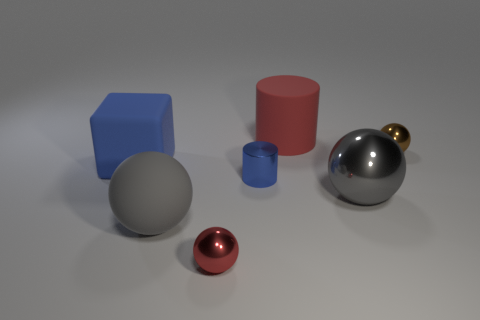Subtract all large gray metallic balls. How many balls are left? 3 Subtract all brown blocks. How many gray spheres are left? 2 Subtract all red spheres. How many spheres are left? 3 Add 2 small blue rubber things. How many objects exist? 9 Subtract all spheres. How many objects are left? 3 Subtract all purple balls. Subtract all yellow cylinders. How many balls are left? 4 Subtract 0 gray cylinders. How many objects are left? 7 Subtract all gray rubber balls. Subtract all large gray metal things. How many objects are left? 5 Add 5 small red shiny objects. How many small red shiny objects are left? 6 Add 1 red cylinders. How many red cylinders exist? 2 